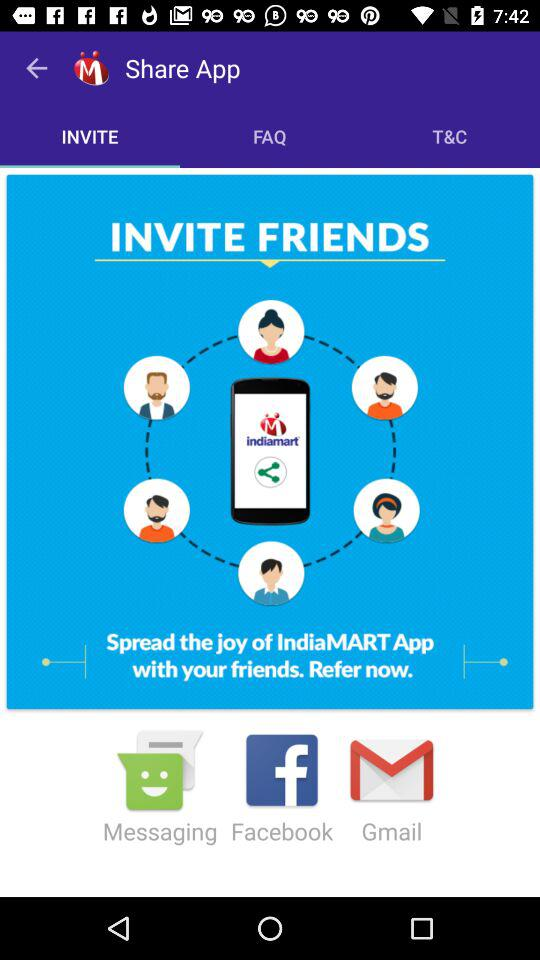Which tab is selected? The selected tab is "INVITE". 